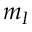Convert formula to latex. <formula><loc_0><loc_0><loc_500><loc_500>m _ { I }</formula> 